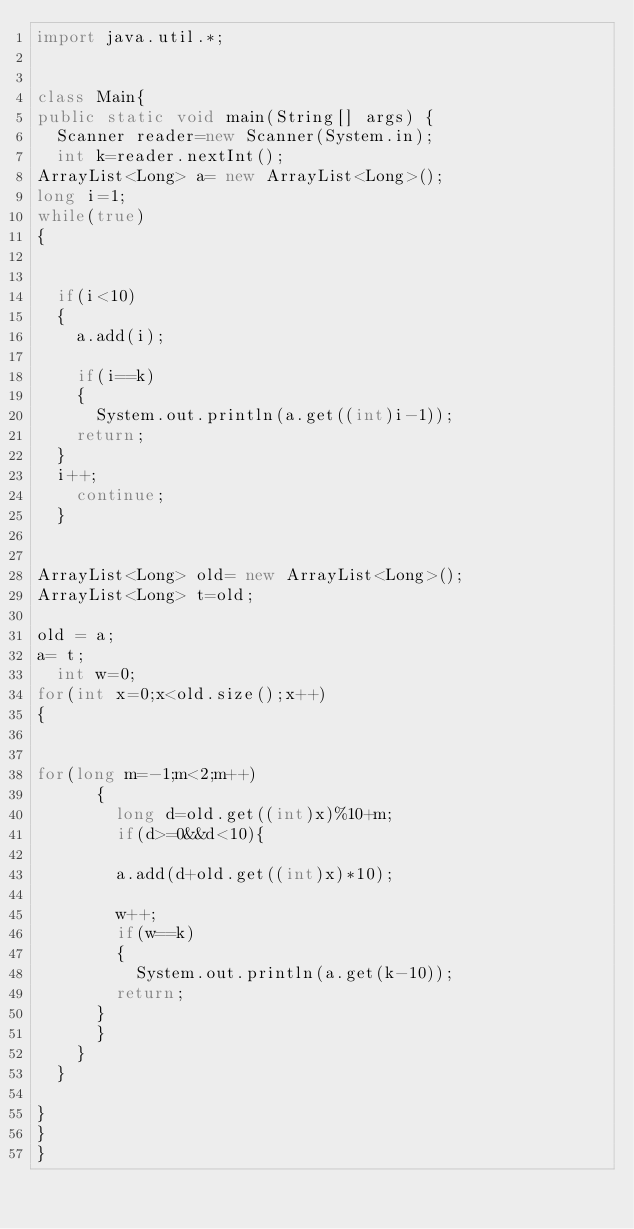<code> <loc_0><loc_0><loc_500><loc_500><_Java_>import java.util.*;


class Main{
public static void main(String[] args) {
  Scanner reader=new Scanner(System.in);
  int k=reader.nextInt();
ArrayList<Long> a= new ArrayList<Long>();
long i=1;
while(true)
{


  if(i<10)
  {
    a.add(i);

    if(i==k)
    {
      System.out.println(a.get((int)i-1));
    return;
  }
  i++;
    continue;
  }


ArrayList<Long> old= new ArrayList<Long>();
ArrayList<Long> t=old;

old = a;
a= t;
  int w=0;
for(int x=0;x<old.size();x++)
{


for(long m=-1;m<2;m++)
      {
        long d=old.get((int)x)%10+m;
        if(d>=0&&d<10){

        a.add(d+old.get((int)x)*10);

        w++;
        if(w==k)
        {
          System.out.println(a.get(k-10));
        return;
      }
      }
    }
  }

}
}
}</code> 